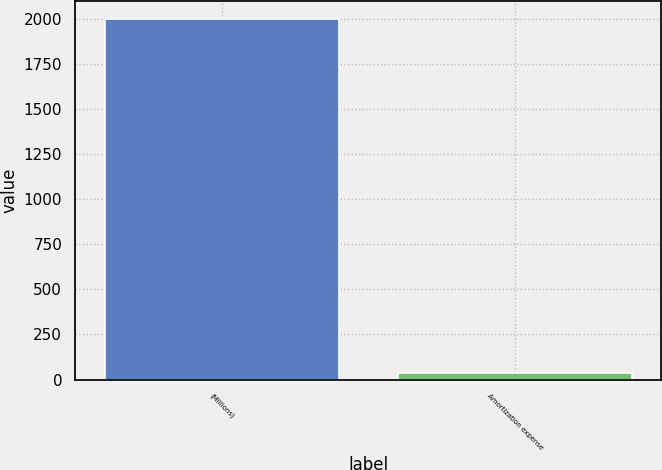Convert chart. <chart><loc_0><loc_0><loc_500><loc_500><bar_chart><fcel>(Millions)<fcel>Amortization expense<nl><fcel>2002<fcel>39<nl></chart> 